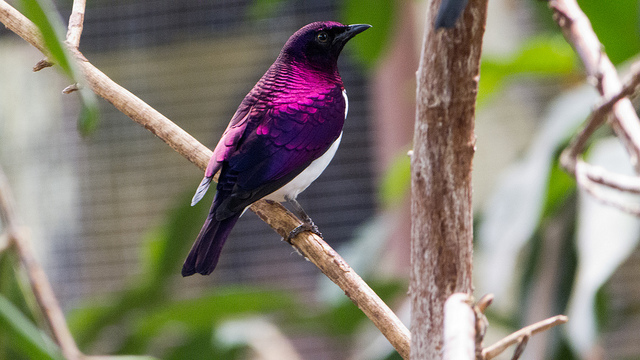What do you see happening in this image? The image captures a beautiful bird, likely an Amethyst Starling, prominently perched on a branch. The bird's vibrant purple plumage stands out against the natural backdrop, creating a striking visual contrast. The focus on the bird highlights its exquisite coloration and the serene environment it inhabits. 